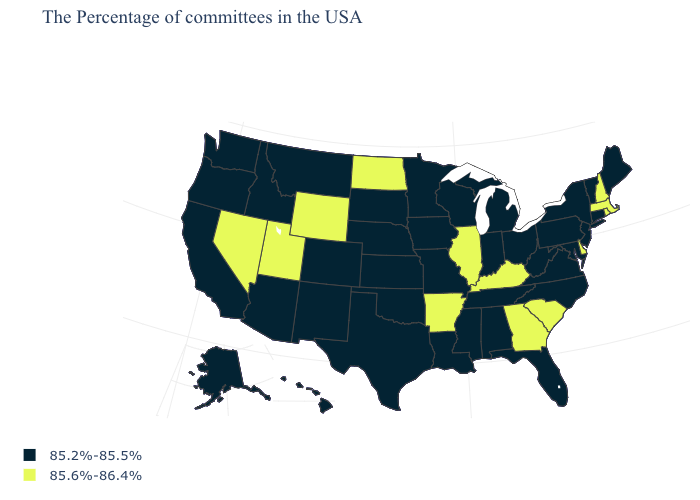What is the highest value in the USA?
Answer briefly. 85.6%-86.4%. Which states have the lowest value in the West?
Be succinct. Colorado, New Mexico, Montana, Arizona, Idaho, California, Washington, Oregon, Alaska, Hawaii. Does Minnesota have the same value as Massachusetts?
Concise answer only. No. Does Utah have the highest value in the USA?
Short answer required. Yes. Does Utah have the highest value in the West?
Quick response, please. Yes. Which states have the lowest value in the MidWest?
Keep it brief. Ohio, Michigan, Indiana, Wisconsin, Missouri, Minnesota, Iowa, Kansas, Nebraska, South Dakota. Name the states that have a value in the range 85.2%-85.5%?
Answer briefly. Maine, Vermont, Connecticut, New York, New Jersey, Maryland, Pennsylvania, Virginia, North Carolina, West Virginia, Ohio, Florida, Michigan, Indiana, Alabama, Tennessee, Wisconsin, Mississippi, Louisiana, Missouri, Minnesota, Iowa, Kansas, Nebraska, Oklahoma, Texas, South Dakota, Colorado, New Mexico, Montana, Arizona, Idaho, California, Washington, Oregon, Alaska, Hawaii. Name the states that have a value in the range 85.6%-86.4%?
Concise answer only. Massachusetts, Rhode Island, New Hampshire, Delaware, South Carolina, Georgia, Kentucky, Illinois, Arkansas, North Dakota, Wyoming, Utah, Nevada. What is the highest value in the West ?
Write a very short answer. 85.6%-86.4%. Name the states that have a value in the range 85.6%-86.4%?
Be succinct. Massachusetts, Rhode Island, New Hampshire, Delaware, South Carolina, Georgia, Kentucky, Illinois, Arkansas, North Dakota, Wyoming, Utah, Nevada. What is the highest value in the USA?
Give a very brief answer. 85.6%-86.4%. What is the highest value in the MidWest ?
Short answer required. 85.6%-86.4%. Name the states that have a value in the range 85.2%-85.5%?
Give a very brief answer. Maine, Vermont, Connecticut, New York, New Jersey, Maryland, Pennsylvania, Virginia, North Carolina, West Virginia, Ohio, Florida, Michigan, Indiana, Alabama, Tennessee, Wisconsin, Mississippi, Louisiana, Missouri, Minnesota, Iowa, Kansas, Nebraska, Oklahoma, Texas, South Dakota, Colorado, New Mexico, Montana, Arizona, Idaho, California, Washington, Oregon, Alaska, Hawaii. Name the states that have a value in the range 85.6%-86.4%?
Short answer required. Massachusetts, Rhode Island, New Hampshire, Delaware, South Carolina, Georgia, Kentucky, Illinois, Arkansas, North Dakota, Wyoming, Utah, Nevada. What is the lowest value in states that border South Carolina?
Quick response, please. 85.2%-85.5%. 